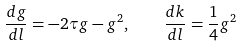Convert formula to latex. <formula><loc_0><loc_0><loc_500><loc_500>\frac { d g } { d l } = - 2 \tau g - g ^ { 2 } , \quad \frac { d k } { d l } = \frac { 1 } { 4 } g ^ { 2 }</formula> 